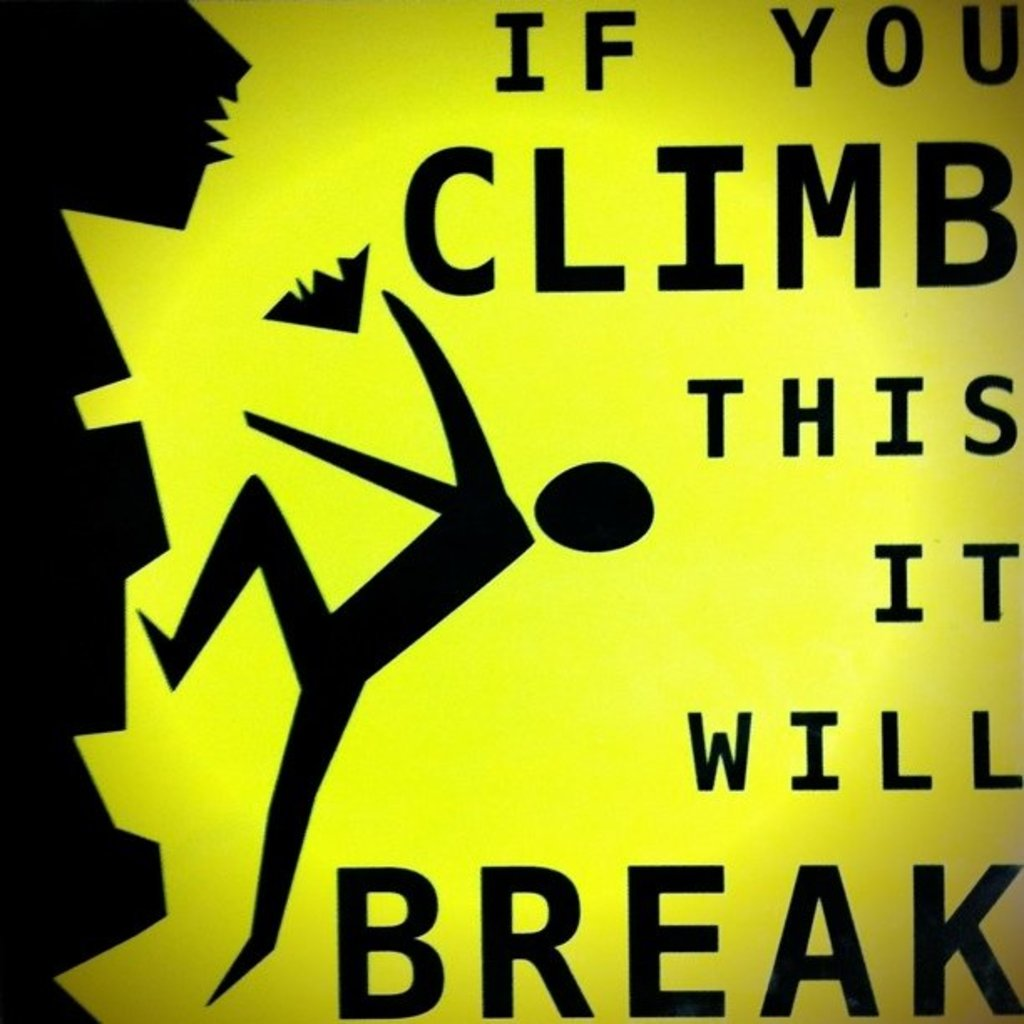Where might this type of sign be typically used and why? This type of sign is commonly used in construction areas, unsafe buildings, or around fragile art installations. These locations are prone to accidents due to unstable structures or redevelopment work where temporary structures might not support heavy weight. The sign acts as both a safety precaution and a legal shield against liability for injuries, emphasizing areas where human interaction could lead to damage or danger. Could this sign be effective in a park setting? Absolutely, particularly in parks with historical monuments, delicate sculptures, or newly planted trees. These items might not withstand the strain of climbing and could be easily damaged. Placing such signs helps preserve these features, ensuring that they are not harmed by visitors unaware of their fragility. It also helps park management maintain the site's integrity and beauty for all visitors. 